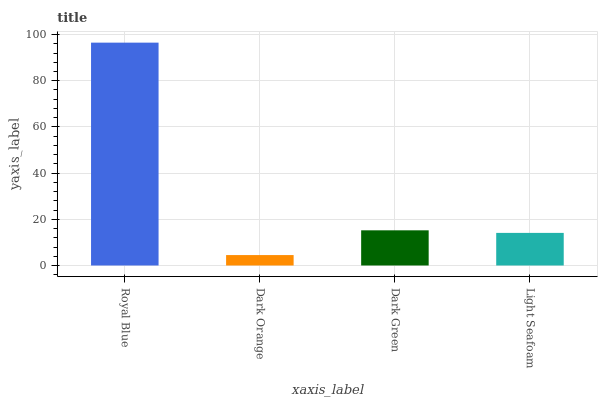Is Dark Green the minimum?
Answer yes or no. No. Is Dark Green the maximum?
Answer yes or no. No. Is Dark Green greater than Dark Orange?
Answer yes or no. Yes. Is Dark Orange less than Dark Green?
Answer yes or no. Yes. Is Dark Orange greater than Dark Green?
Answer yes or no. No. Is Dark Green less than Dark Orange?
Answer yes or no. No. Is Dark Green the high median?
Answer yes or no. Yes. Is Light Seafoam the low median?
Answer yes or no. Yes. Is Dark Orange the high median?
Answer yes or no. No. Is Dark Orange the low median?
Answer yes or no. No. 